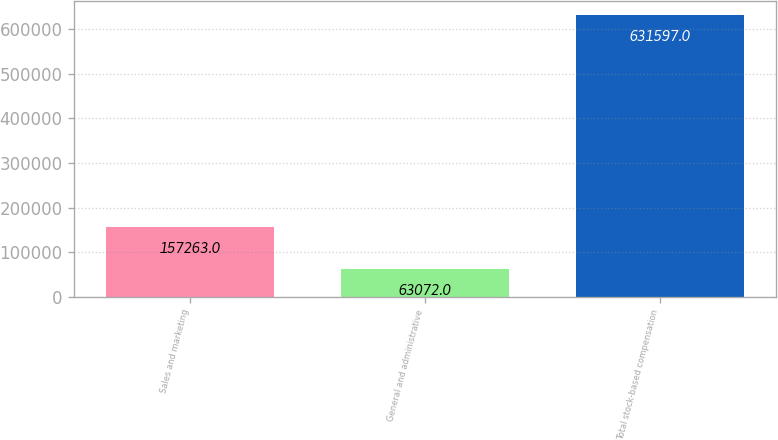<chart> <loc_0><loc_0><loc_500><loc_500><bar_chart><fcel>Sales and marketing<fcel>General and administrative<fcel>Total stock-based compensation<nl><fcel>157263<fcel>63072<fcel>631597<nl></chart> 